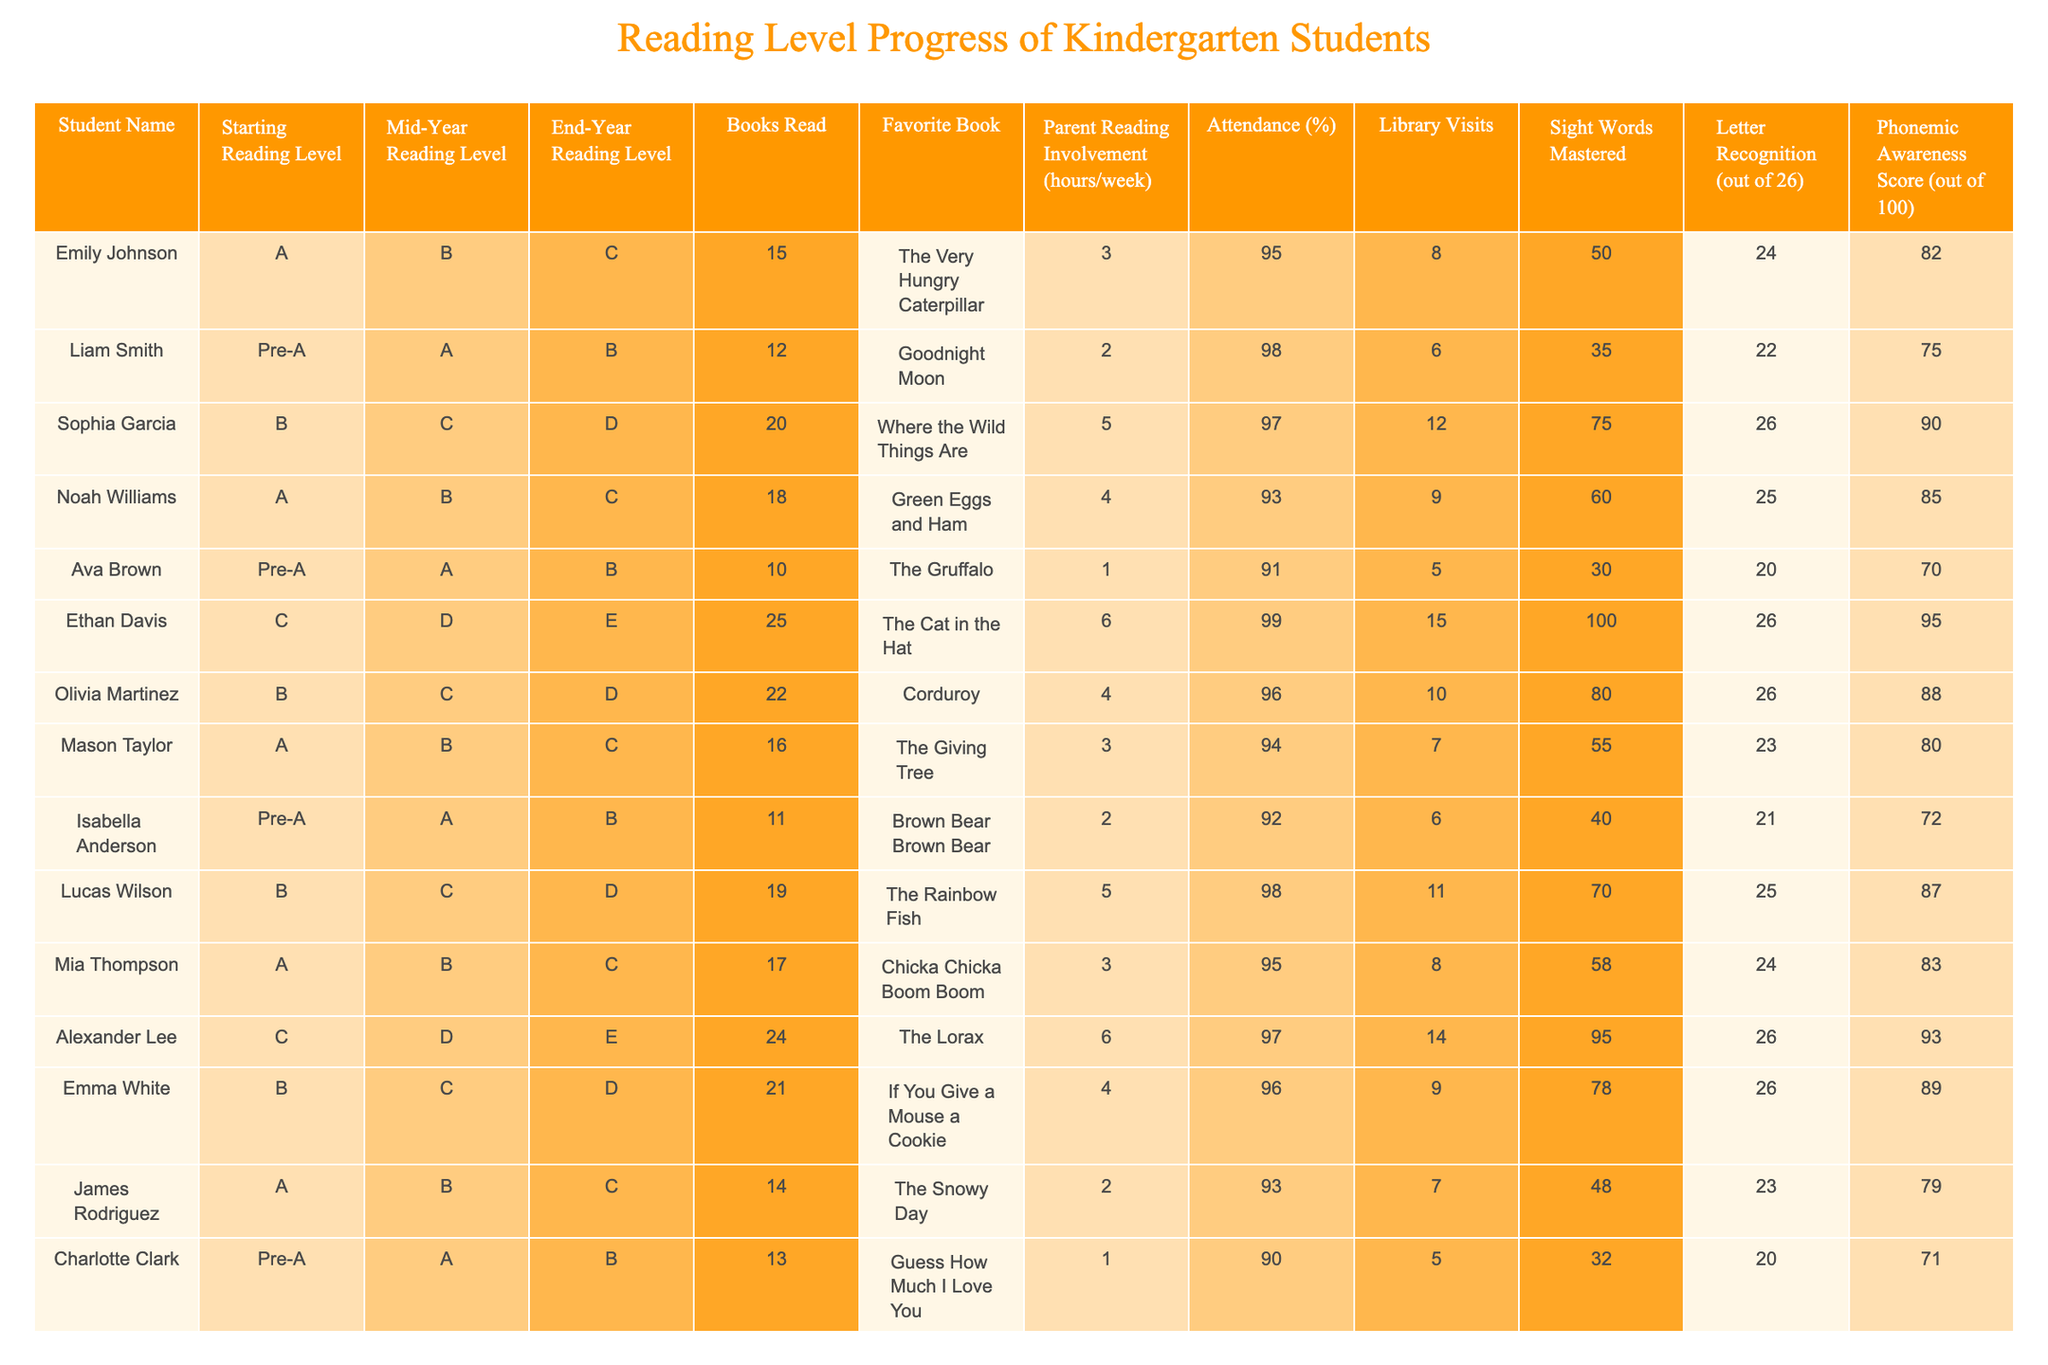What is the favorite book of Ethan Davis? The table shows that Ethan Davis's favorite book is "The Cat in the Hat."
Answer: The Cat in the Hat What reading level did Sophia Garcia start with? According to the table, Sophia Garcia started with a reading level of B.
Answer: B How many books did Mia Thompson read? The table indicates that Mia Thompson read 17 books.
Answer: 17 What is the average attendance percentage of all students? To find the average, add all attendance percentages: 95 + 98 + 97 + 93 + 91 + 99 + 96 + 94 + 92 + 98 + 95 + 97 + 96 + 90 = 96.43, and then divide by 14 (the number of students) which gives approximately 95% when rounded.
Answer: 95% Did any students master more than 70 sight words? Yes, the table shows that all students mastered sight words. The number of mastered words varies, but each student has more than 70 sight words.
Answer: Yes How many hours per week did Alexander Lee's parents read to him? The table shows that Alexander Lee had 6 hours of parent reading involvement per week.
Answer: 6 Which student had the highest phonemic awareness score and what was that score? The highest phonemic awareness score in the table is 100, achieved by Ethan Davis.
Answer: 100 What is the difference in the end-year reading level between Noah Williams and Emma White? The end-year reading level for Noah Williams is C and for Emma White is D. C is one level below D, indicating a difference of one level between them.
Answer: 1 level Which student had the most library visits? The table indicates that Ethan Davis had the most library visits, totaling 15.
Answer: 15 What is the median starting reading level among the students? The starting reading levels are: A, B, Pre-A, B, A, C, Pre-A, A, B, B, C, A, Pre-A. Sorting these gives: Pre-A, Pre-A, A, A, A, B, B, B, B, C, C. The median (middle value in ordered list of 14) is B.
Answer: B How many students had a mid-year reading level of C? From the table, the students with a mid-year reading level of C are Sophia Garcia, Mason Taylor, Olivia Martinez, and Emma White—totaling 4 students.
Answer: 4 